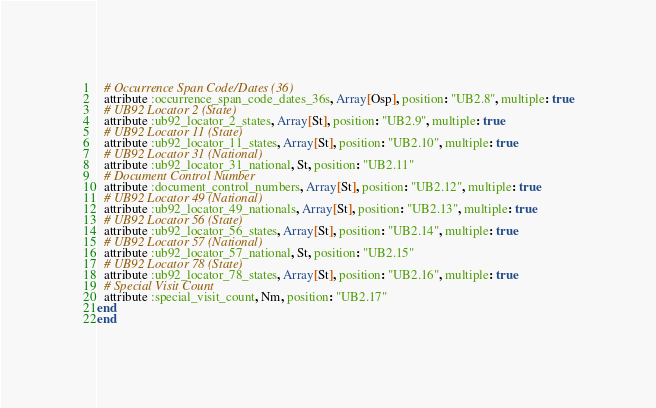<code> <loc_0><loc_0><loc_500><loc_500><_Ruby_>  # Occurrence Span Code/Dates (36)
  attribute :occurrence_span_code_dates_36s, Array[Osp], position: "UB2.8", multiple: true
  # UB92 Locator 2 (State)
  attribute :ub92_locator_2_states, Array[St], position: "UB2.9", multiple: true
  # UB92 Locator 11 (State)
  attribute :ub92_locator_11_states, Array[St], position: "UB2.10", multiple: true
  # UB92 Locator 31 (National)
  attribute :ub92_locator_31_national, St, position: "UB2.11"
  # Document Control Number
  attribute :document_control_numbers, Array[St], position: "UB2.12", multiple: true
  # UB92 Locator 49 (National)
  attribute :ub92_locator_49_nationals, Array[St], position: "UB2.13", multiple: true
  # UB92 Locator 56 (State)
  attribute :ub92_locator_56_states, Array[St], position: "UB2.14", multiple: true
  # UB92 Locator 57 (National)
  attribute :ub92_locator_57_national, St, position: "UB2.15"
  # UB92 Locator 78 (State)
  attribute :ub92_locator_78_states, Array[St], position: "UB2.16", multiple: true
  # Special Visit Count
  attribute :special_visit_count, Nm, position: "UB2.17"
end
end</code> 